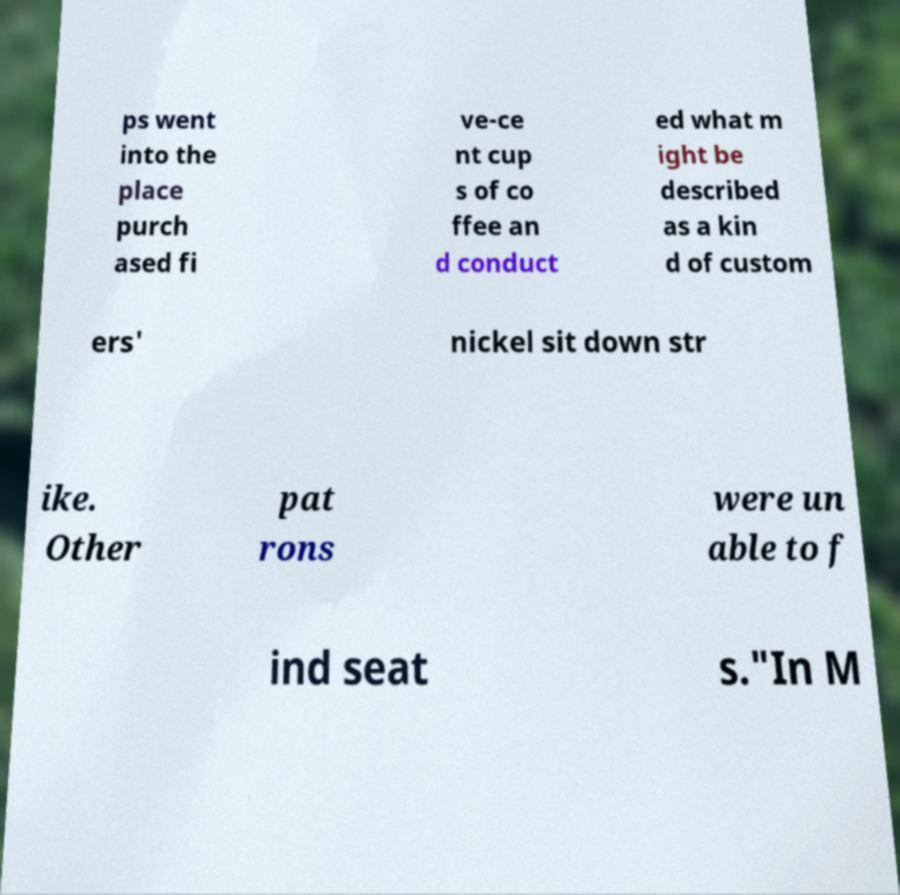I need the written content from this picture converted into text. Can you do that? ps went into the place purch ased fi ve-ce nt cup s of co ffee an d conduct ed what m ight be described as a kin d of custom ers' nickel sit down str ike. Other pat rons were un able to f ind seat s."In M 